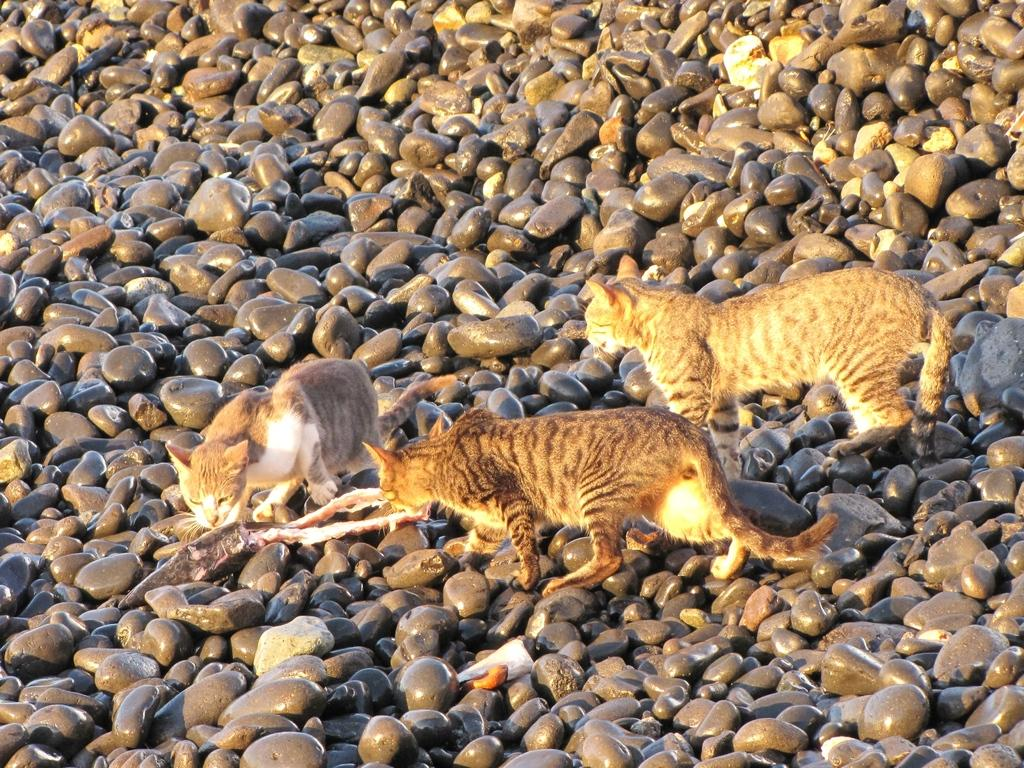How many cats are present in the image? There are three cats in the image. What are the cats standing on? The cats are standing on small stones. What type of loaf is the man holding in the image? There is no man or loaf present in the image; it features three cats standing on small stones. 